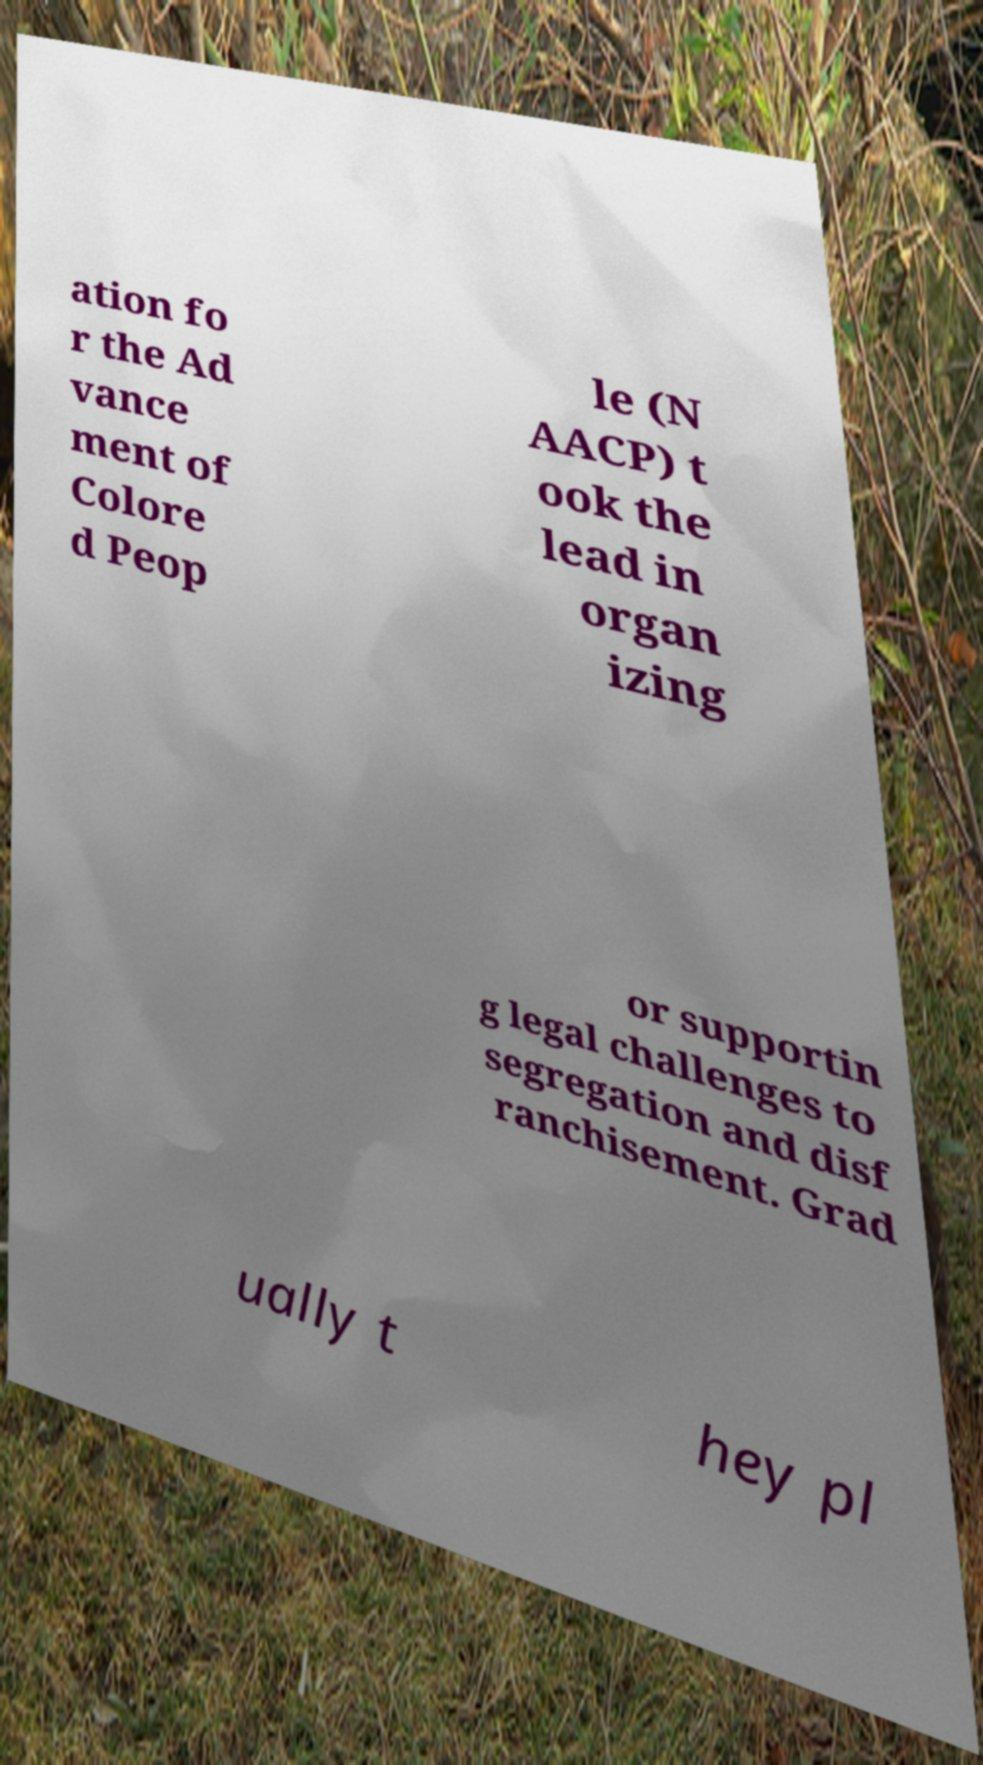Can you read and provide the text displayed in the image?This photo seems to have some interesting text. Can you extract and type it out for me? ation fo r the Ad vance ment of Colore d Peop le (N AACP) t ook the lead in organ izing or supportin g legal challenges to segregation and disf ranchisement. Grad ually t hey pl 